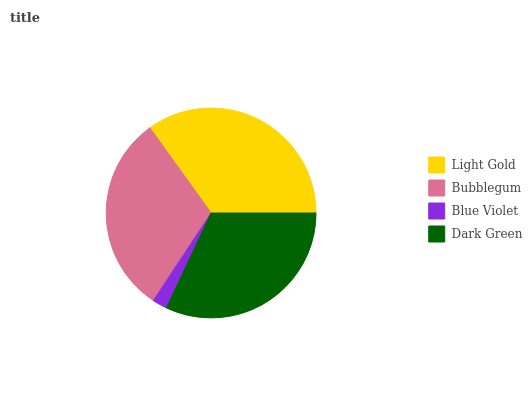Is Blue Violet the minimum?
Answer yes or no. Yes. Is Light Gold the maximum?
Answer yes or no. Yes. Is Bubblegum the minimum?
Answer yes or no. No. Is Bubblegum the maximum?
Answer yes or no. No. Is Light Gold greater than Bubblegum?
Answer yes or no. Yes. Is Bubblegum less than Light Gold?
Answer yes or no. Yes. Is Bubblegum greater than Light Gold?
Answer yes or no. No. Is Light Gold less than Bubblegum?
Answer yes or no. No. Is Dark Green the high median?
Answer yes or no. Yes. Is Bubblegum the low median?
Answer yes or no. Yes. Is Bubblegum the high median?
Answer yes or no. No. Is Light Gold the low median?
Answer yes or no. No. 